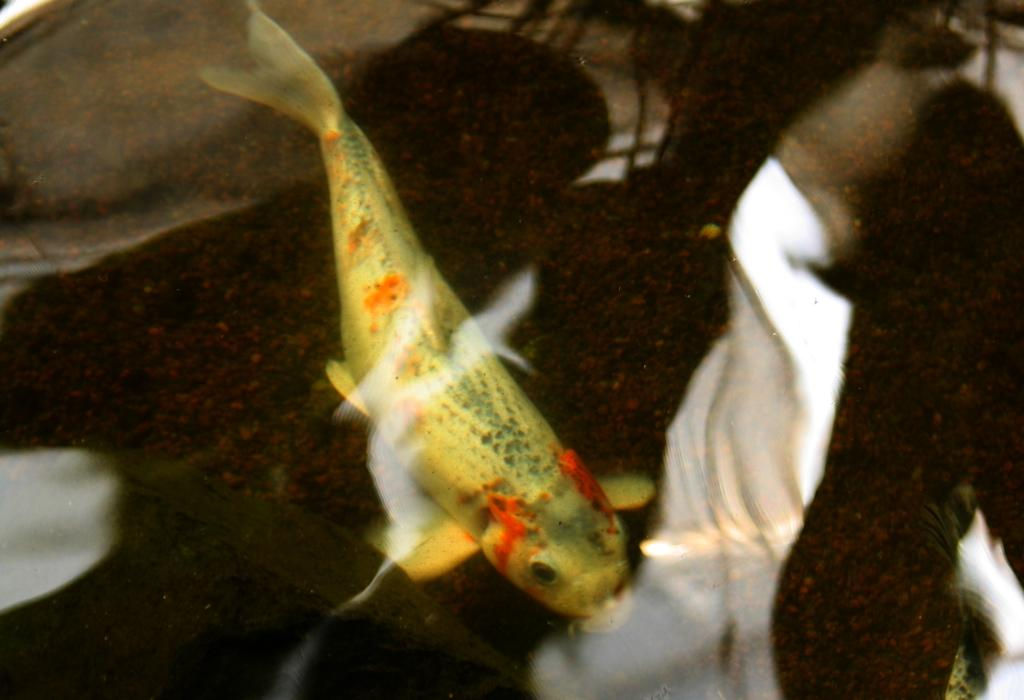What type of animal can be seen in the water in the image? There is a fish in the water in the image. Where is the pig located in the image? There is no pig present in the image. What type of spring can be seen in the image? There is no spring present in the image. 